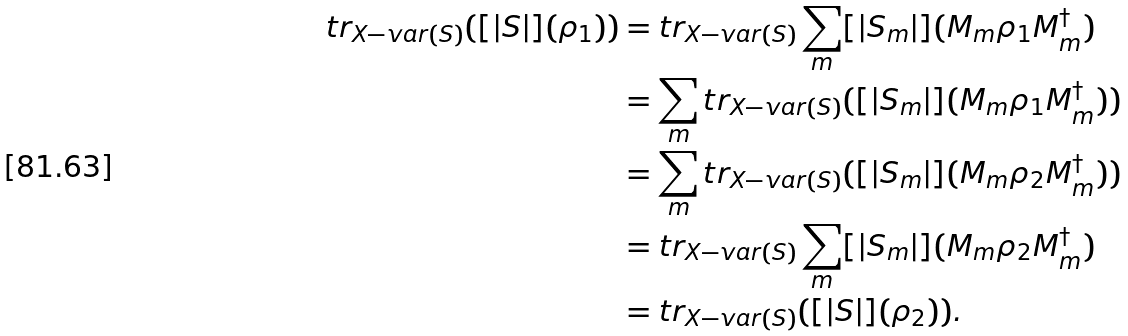<formula> <loc_0><loc_0><loc_500><loc_500>t r _ { X - v a r ( S ) } ( [ | S | ] ( \rho _ { 1 } ) ) & = t r _ { X - v a r ( S ) } \sum _ { m } [ | S _ { m } | ] ( M _ { m } \rho _ { 1 } M _ { m } ^ { \dag } ) \\ & = \sum _ { m } t r _ { X - v a r ( S ) } ( [ | S _ { m } | ] ( M _ { m } \rho _ { 1 } M _ { m } ^ { \dag } ) ) \\ & = \sum _ { m } t r _ { X - v a r ( S ) } ( [ | S _ { m } | ] ( M _ { m } \rho _ { 2 } M _ { m } ^ { \dag } ) ) \\ & = t r _ { X - v a r ( S ) } \sum _ { m } [ | S _ { m } | ] ( M _ { m } \rho _ { 2 } M _ { m } ^ { \dag } ) \\ & = t r _ { X - v a r ( S ) } ( [ | S | ] ( \rho _ { 2 } ) ) .</formula> 